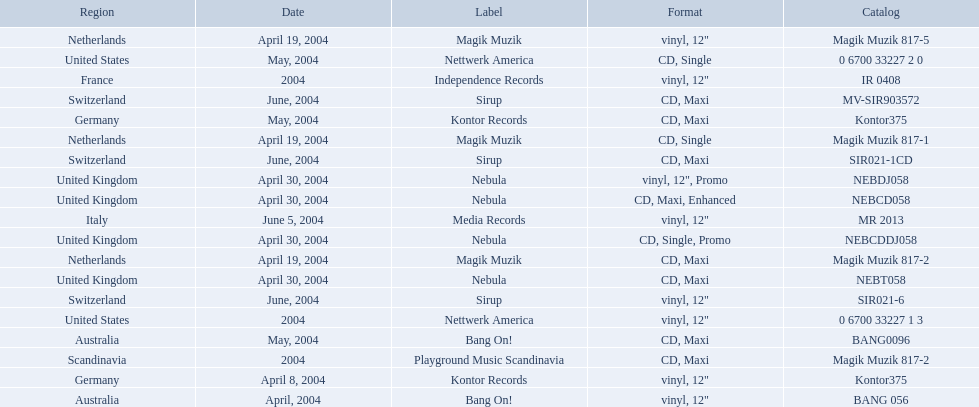What are the labels for love comes again? Magik Muzik, Magik Muzik, Magik Muzik, Kontor Records, Kontor Records, Bang On!, Bang On!, Nebula, Nebula, Nebula, Nebula, Sirup, Sirup, Sirup, Nettwerk America, Nettwerk America, Independence Records, Media Records, Playground Music Scandinavia. What label has been used by the region of france? Independence Records. 